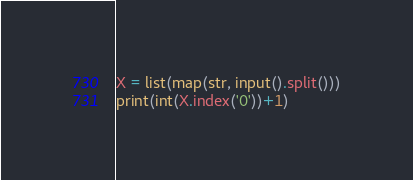<code> <loc_0><loc_0><loc_500><loc_500><_Python_>X = list(map(str, input().split()))
print(int(X.index('0'))+1)</code> 